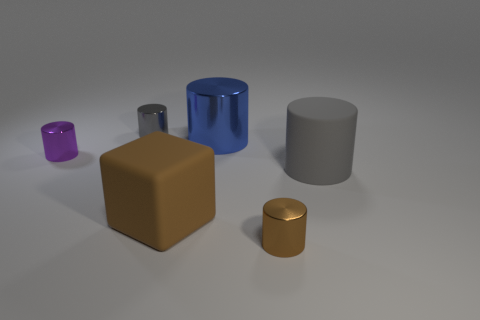How many things are the same color as the large rubber cylinder?
Provide a short and direct response. 1. Is there anything else that is the same color as the matte cube?
Your response must be concise. Yes. There is a large rubber object on the left side of the large metallic thing; is it the same color as the object in front of the matte cube?
Your answer should be compact. Yes. The small object that is the same color as the large block is what shape?
Provide a succinct answer. Cylinder. What number of brown rubber things are on the left side of the brown rubber block?
Your response must be concise. 0. Do the small gray metallic object and the big brown object have the same shape?
Make the answer very short. No. How many small things are on the right side of the large brown object and behind the blue metallic thing?
Keep it short and to the point. 0. What number of objects are brown objects or cylinders that are right of the tiny gray metallic cylinder?
Offer a terse response. 4. Is the number of brown cylinders greater than the number of large green rubber cylinders?
Keep it short and to the point. Yes. What shape is the brown thing that is in front of the large brown rubber cube?
Your answer should be very brief. Cylinder. 